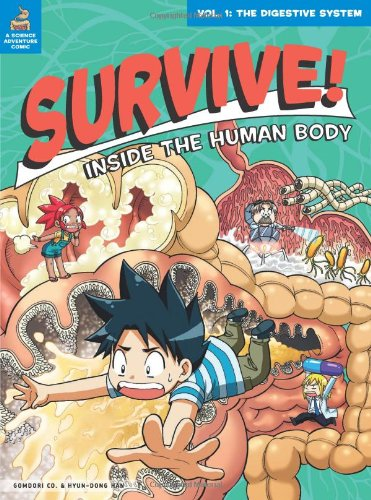Apart from the digestive system, does this series cover other bodily systems? Yes, 'Survive! Inside the Human Body' is a series, and each volume explores a different system, such as the circulatory and nervous systems, using the same storytelling and visual techniques. 